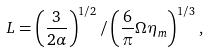Convert formula to latex. <formula><loc_0><loc_0><loc_500><loc_500>L = \left ( \frac { 3 } { 2 \alpha } \right ) ^ { 1 / 2 } / \left ( \frac { 6 } { \pi } { \Omega } \eta _ { m } \right ) ^ { 1 / 3 } ,</formula> 